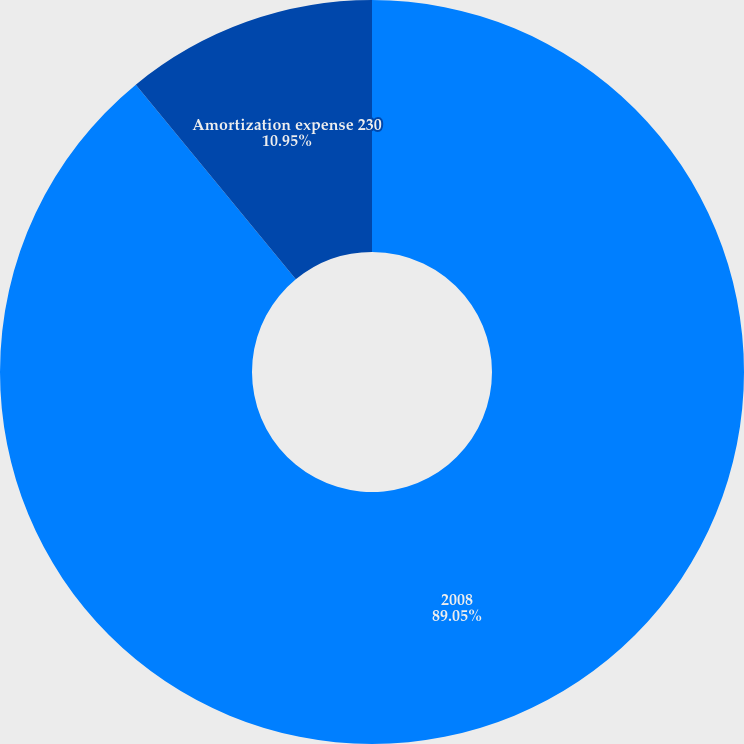Convert chart. <chart><loc_0><loc_0><loc_500><loc_500><pie_chart><fcel>2008<fcel>Amortization expense 230<nl><fcel>89.05%<fcel>10.95%<nl></chart> 